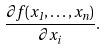<formula> <loc_0><loc_0><loc_500><loc_500>\frac { \partial f ( x _ { 1 } , \dots , x _ { n } ) } { \partial x _ { i } } .</formula> 